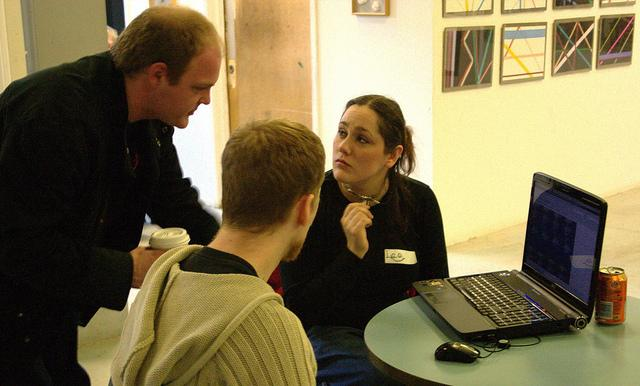What are the people assembled around? laptop 